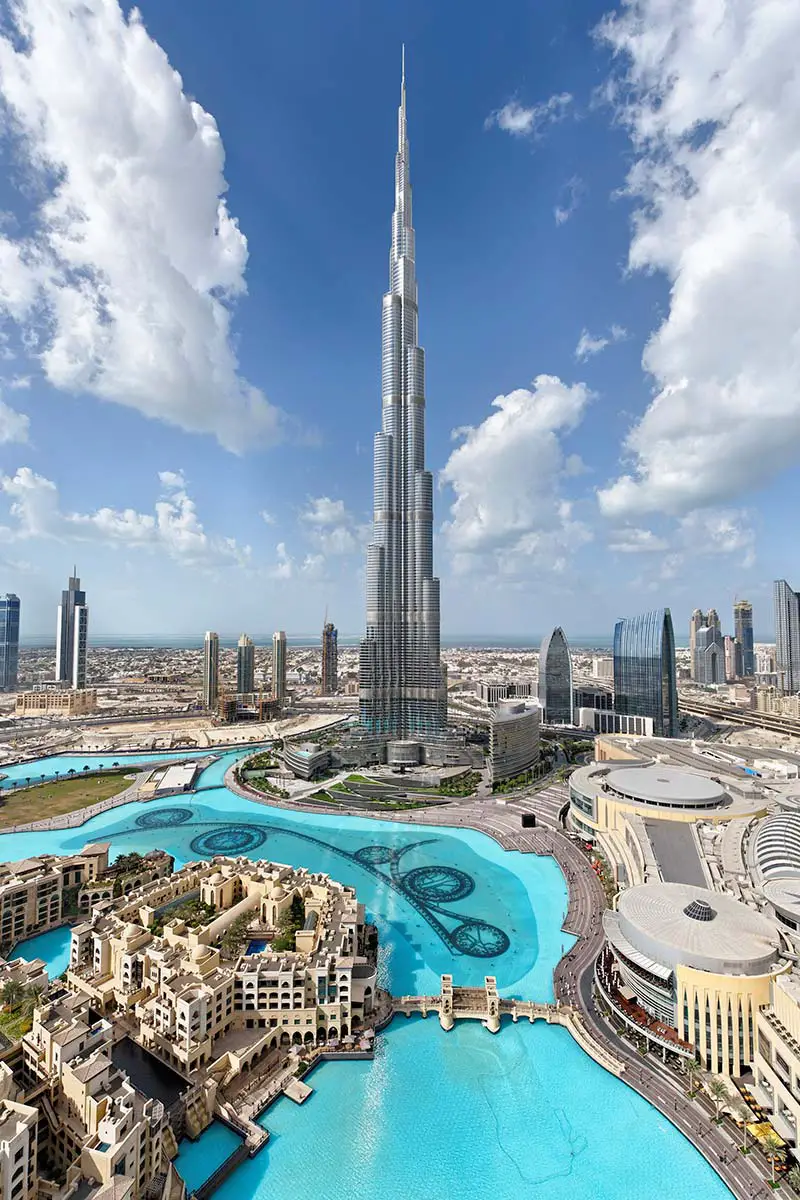What are the key elements in this picture? The dominant feature of this photograph is the Burj Khalifa, known for being the tallest structure in the world, which soars into the clear blue sky of Dubai, United Arab Emirates. Around it, we can see the meticulously designed complex at its base, with traditional architectural influences, and the turquoise waters of the Dubai Fountain. Roads curve gracefully around these focal points, demonstrating the intersection of human innovation and urban planning. Skyscrapers outline the city's ambition and growth, while scattered clouds offer a contrast to the steel and glass, adding a touch of natural beauty to the vibrant city scene. 